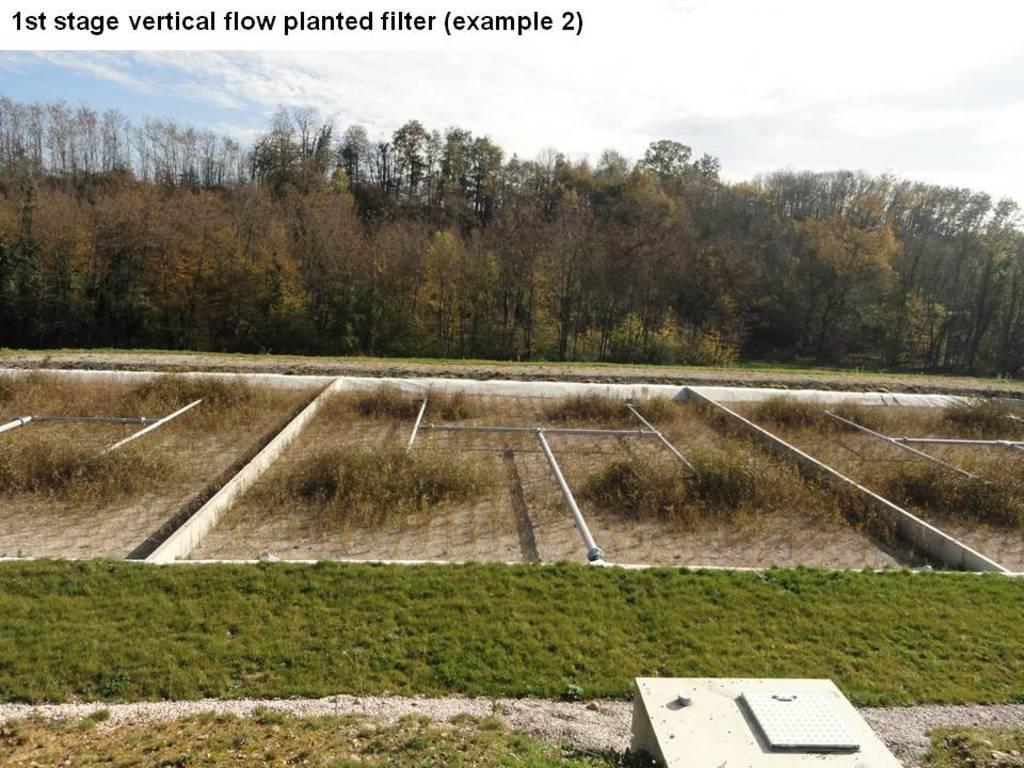Could you give a brief overview of what you see in this image? In this image I can see a forming land , on the land I can see grass and at the top I can see trees and the sky. 